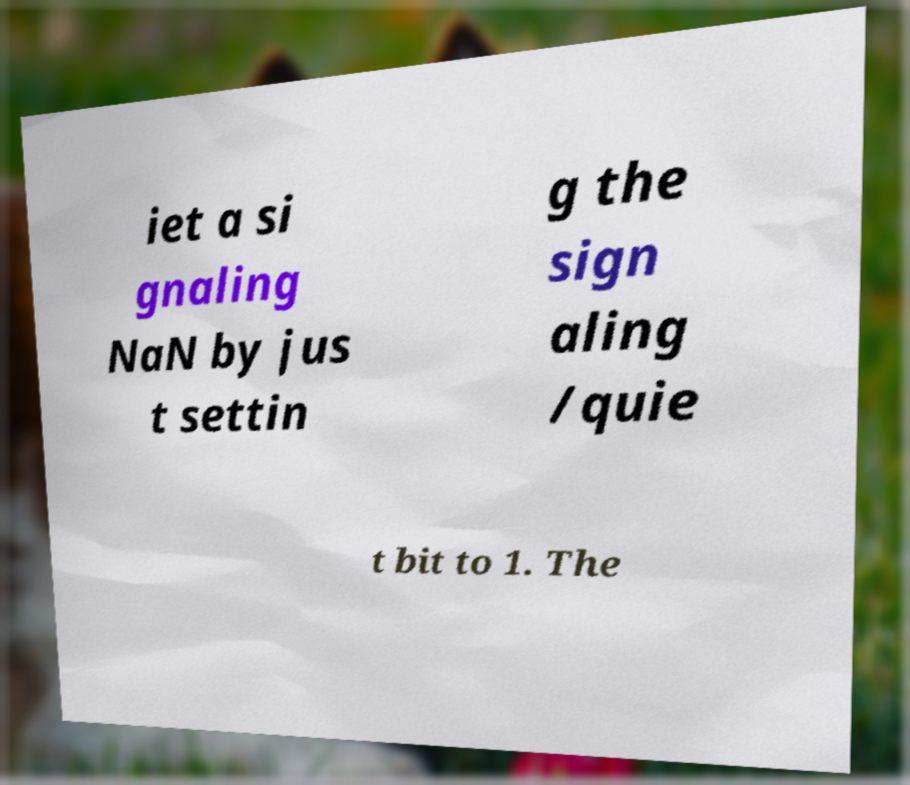Can you accurately transcribe the text from the provided image for me? iet a si gnaling NaN by jus t settin g the sign aling /quie t bit to 1. The 